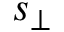<formula> <loc_0><loc_0><loc_500><loc_500>s _ { \perp }</formula> 